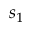<formula> <loc_0><loc_0><loc_500><loc_500>s _ { 1 }</formula> 